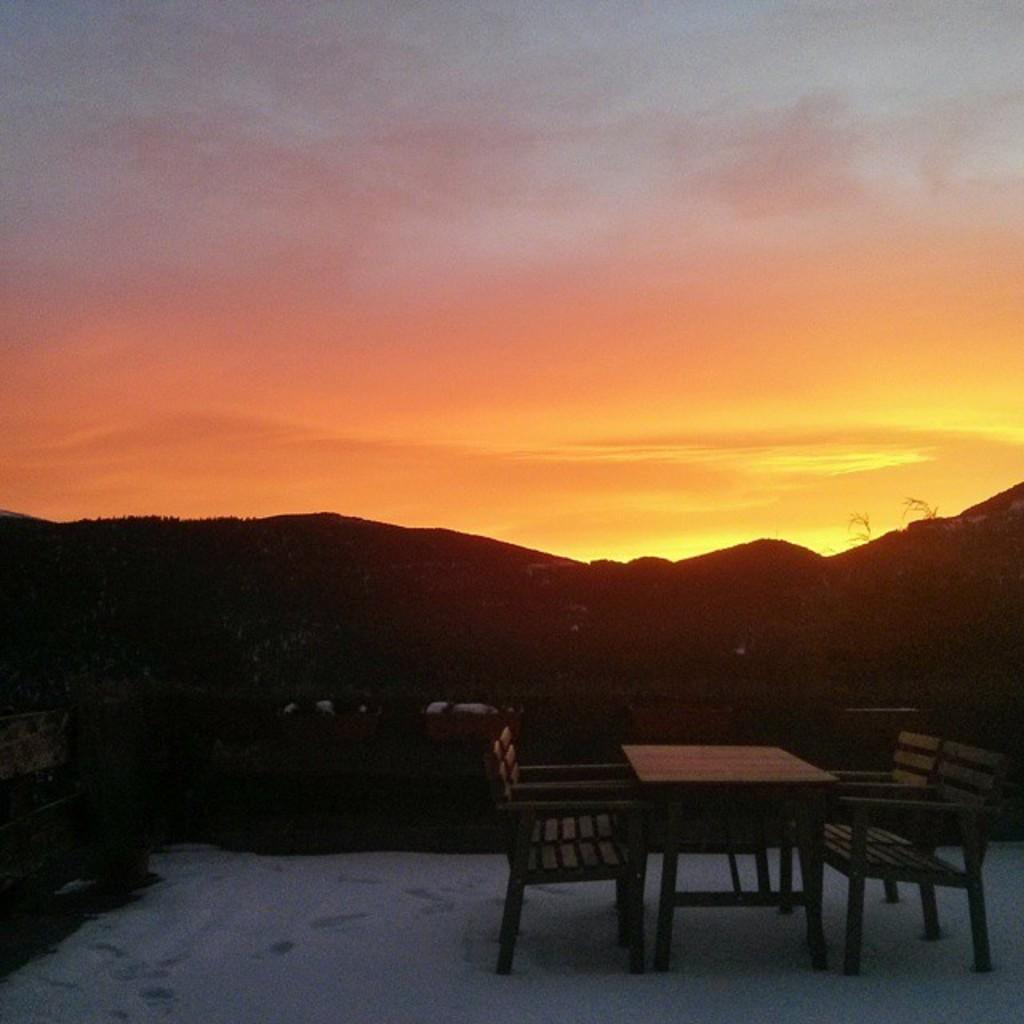What type of furniture is present in the image? There is a table and benches in the image. What can be seen in the background of the image? Mountains are visible in the background of the image. What is visible at the top of the image? The sky is visible at the top of the image. What type of meal is being prepared on the machine in the image? There is no machine or meal preparation visible in the image. What is the attention span of the mountains in the background? The mountains in the background do not have an attention span, as they are inanimate objects. 